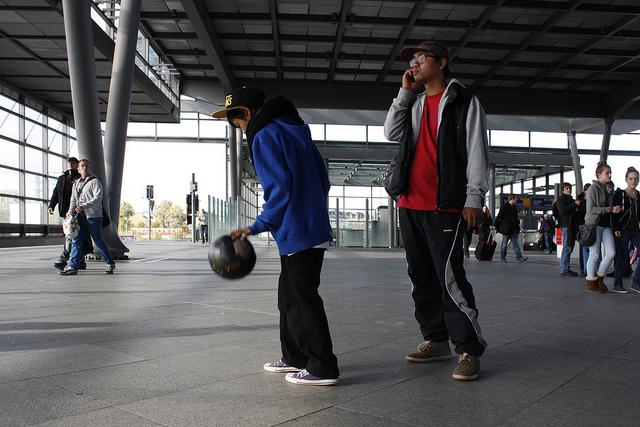What is the boy doing with the black ball? Please explain your reasoning. dribbling. A boy is bouncing a ball with one hand. 